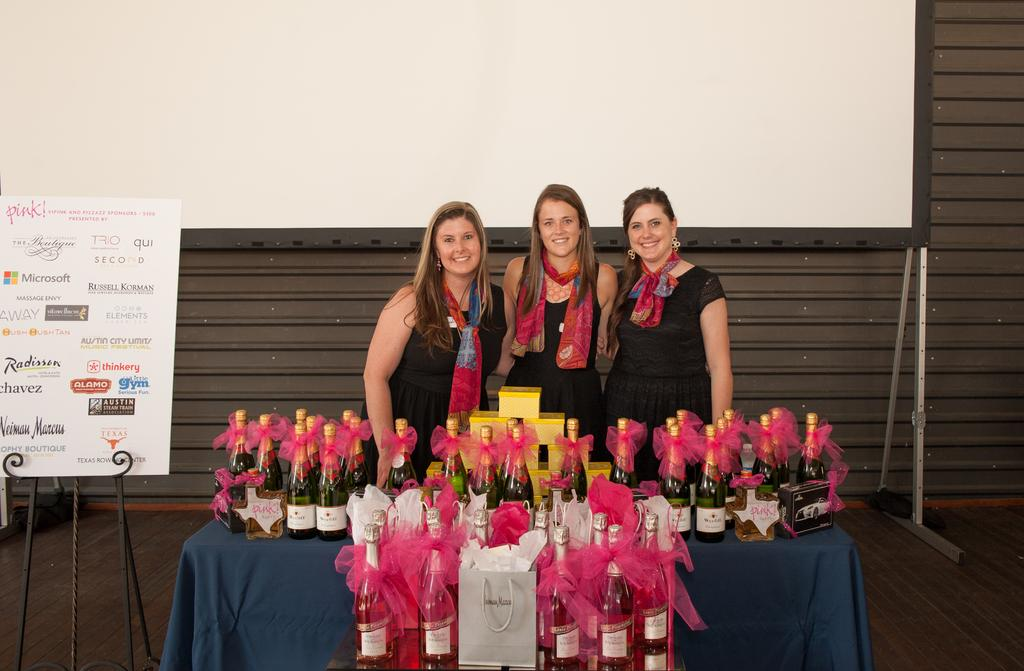How many people are in the image? There are three ladies in the image. What are the ladies doing in the image? The ladies are standing together. What can be seen on the table in the image? There are bottles on the table in the image. What is written or displayed on the board in the image? There is a board with text in the image. What type of railway can be seen in the image? There is no railway present in the image. 